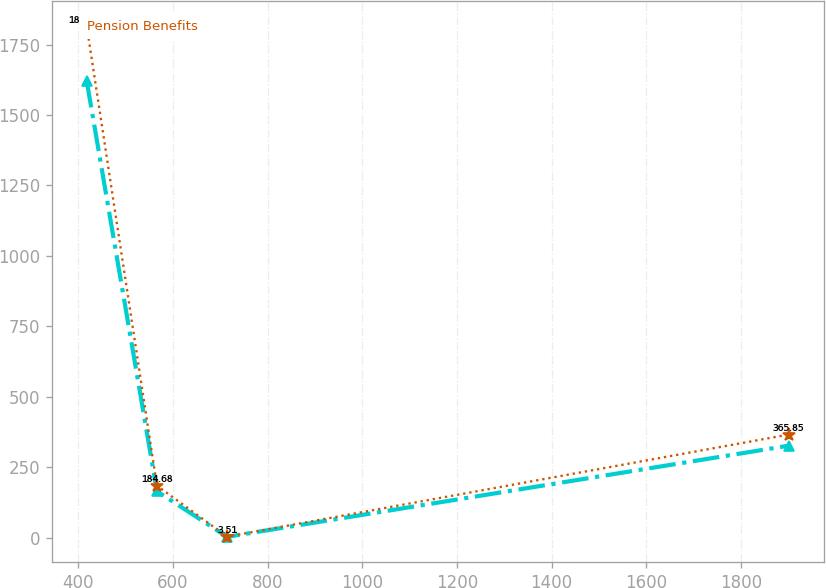Convert chart to OTSL. <chart><loc_0><loc_0><loc_500><loc_500><line_chart><ecel><fcel>Unnamed: 1<fcel>Pension Benefits<nl><fcel>417.7<fcel>1620.22<fcel>1815.21<nl><fcel>566<fcel>164.67<fcel>184.68<nl><fcel>714.3<fcel>2.94<fcel>3.51<nl><fcel>1900.73<fcel>326.4<fcel>365.85<nl></chart> 